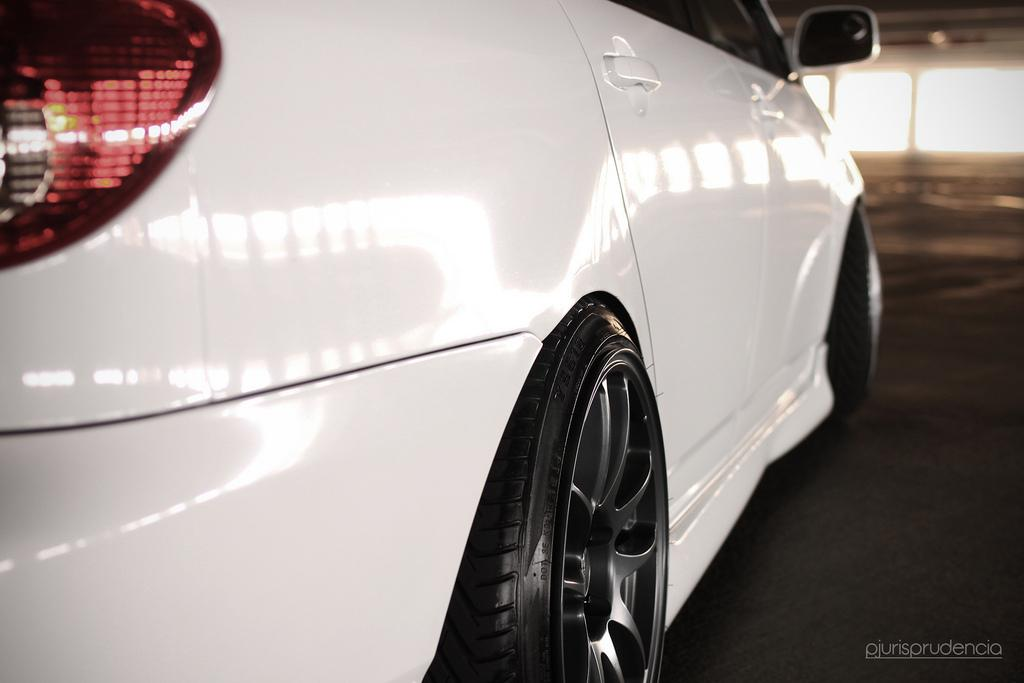What is the main subject of the image? The main subject of the image is a car. Can you describe the background of the image? There is a floor and glass windows visible in the background of the image. What type of cable can be seen hanging from the car in the image? There is no cable visible in the image; it is a truncated view of a car with no visible cables. 